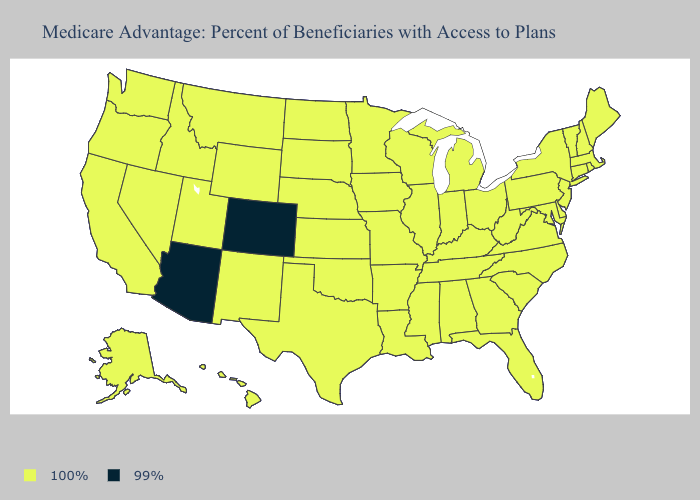What is the value of Wyoming?
Write a very short answer. 100%. Does Alabama have the lowest value in the USA?
Answer briefly. No. What is the lowest value in the MidWest?
Answer briefly. 100%. Does the first symbol in the legend represent the smallest category?
Keep it brief. No. What is the value of Oregon?
Answer briefly. 100%. Name the states that have a value in the range 100%?
Concise answer only. Alaska, Alabama, Arkansas, California, Connecticut, Delaware, Florida, Georgia, Hawaii, Iowa, Idaho, Illinois, Indiana, Kansas, Kentucky, Louisiana, Massachusetts, Maryland, Maine, Michigan, Minnesota, Missouri, Mississippi, Montana, North Carolina, North Dakota, Nebraska, New Hampshire, New Jersey, New Mexico, Nevada, New York, Ohio, Oklahoma, Oregon, Pennsylvania, Rhode Island, South Carolina, South Dakota, Tennessee, Texas, Utah, Virginia, Vermont, Washington, Wisconsin, West Virginia, Wyoming. Which states have the highest value in the USA?
Quick response, please. Alaska, Alabama, Arkansas, California, Connecticut, Delaware, Florida, Georgia, Hawaii, Iowa, Idaho, Illinois, Indiana, Kansas, Kentucky, Louisiana, Massachusetts, Maryland, Maine, Michigan, Minnesota, Missouri, Mississippi, Montana, North Carolina, North Dakota, Nebraska, New Hampshire, New Jersey, New Mexico, Nevada, New York, Ohio, Oklahoma, Oregon, Pennsylvania, Rhode Island, South Carolina, South Dakota, Tennessee, Texas, Utah, Virginia, Vermont, Washington, Wisconsin, West Virginia, Wyoming. What is the value of Alabama?
Write a very short answer. 100%. Among the states that border Nevada , does Arizona have the lowest value?
Write a very short answer. Yes. Name the states that have a value in the range 99%?
Be succinct. Arizona, Colorado. What is the value of New Mexico?
Be succinct. 100%. What is the value of Idaho?
Quick response, please. 100%. What is the value of Michigan?
Keep it brief. 100%. Name the states that have a value in the range 100%?
Concise answer only. Alaska, Alabama, Arkansas, California, Connecticut, Delaware, Florida, Georgia, Hawaii, Iowa, Idaho, Illinois, Indiana, Kansas, Kentucky, Louisiana, Massachusetts, Maryland, Maine, Michigan, Minnesota, Missouri, Mississippi, Montana, North Carolina, North Dakota, Nebraska, New Hampshire, New Jersey, New Mexico, Nevada, New York, Ohio, Oklahoma, Oregon, Pennsylvania, Rhode Island, South Carolina, South Dakota, Tennessee, Texas, Utah, Virginia, Vermont, Washington, Wisconsin, West Virginia, Wyoming. 